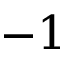Convert formula to latex. <formula><loc_0><loc_0><loc_500><loc_500>- 1</formula> 